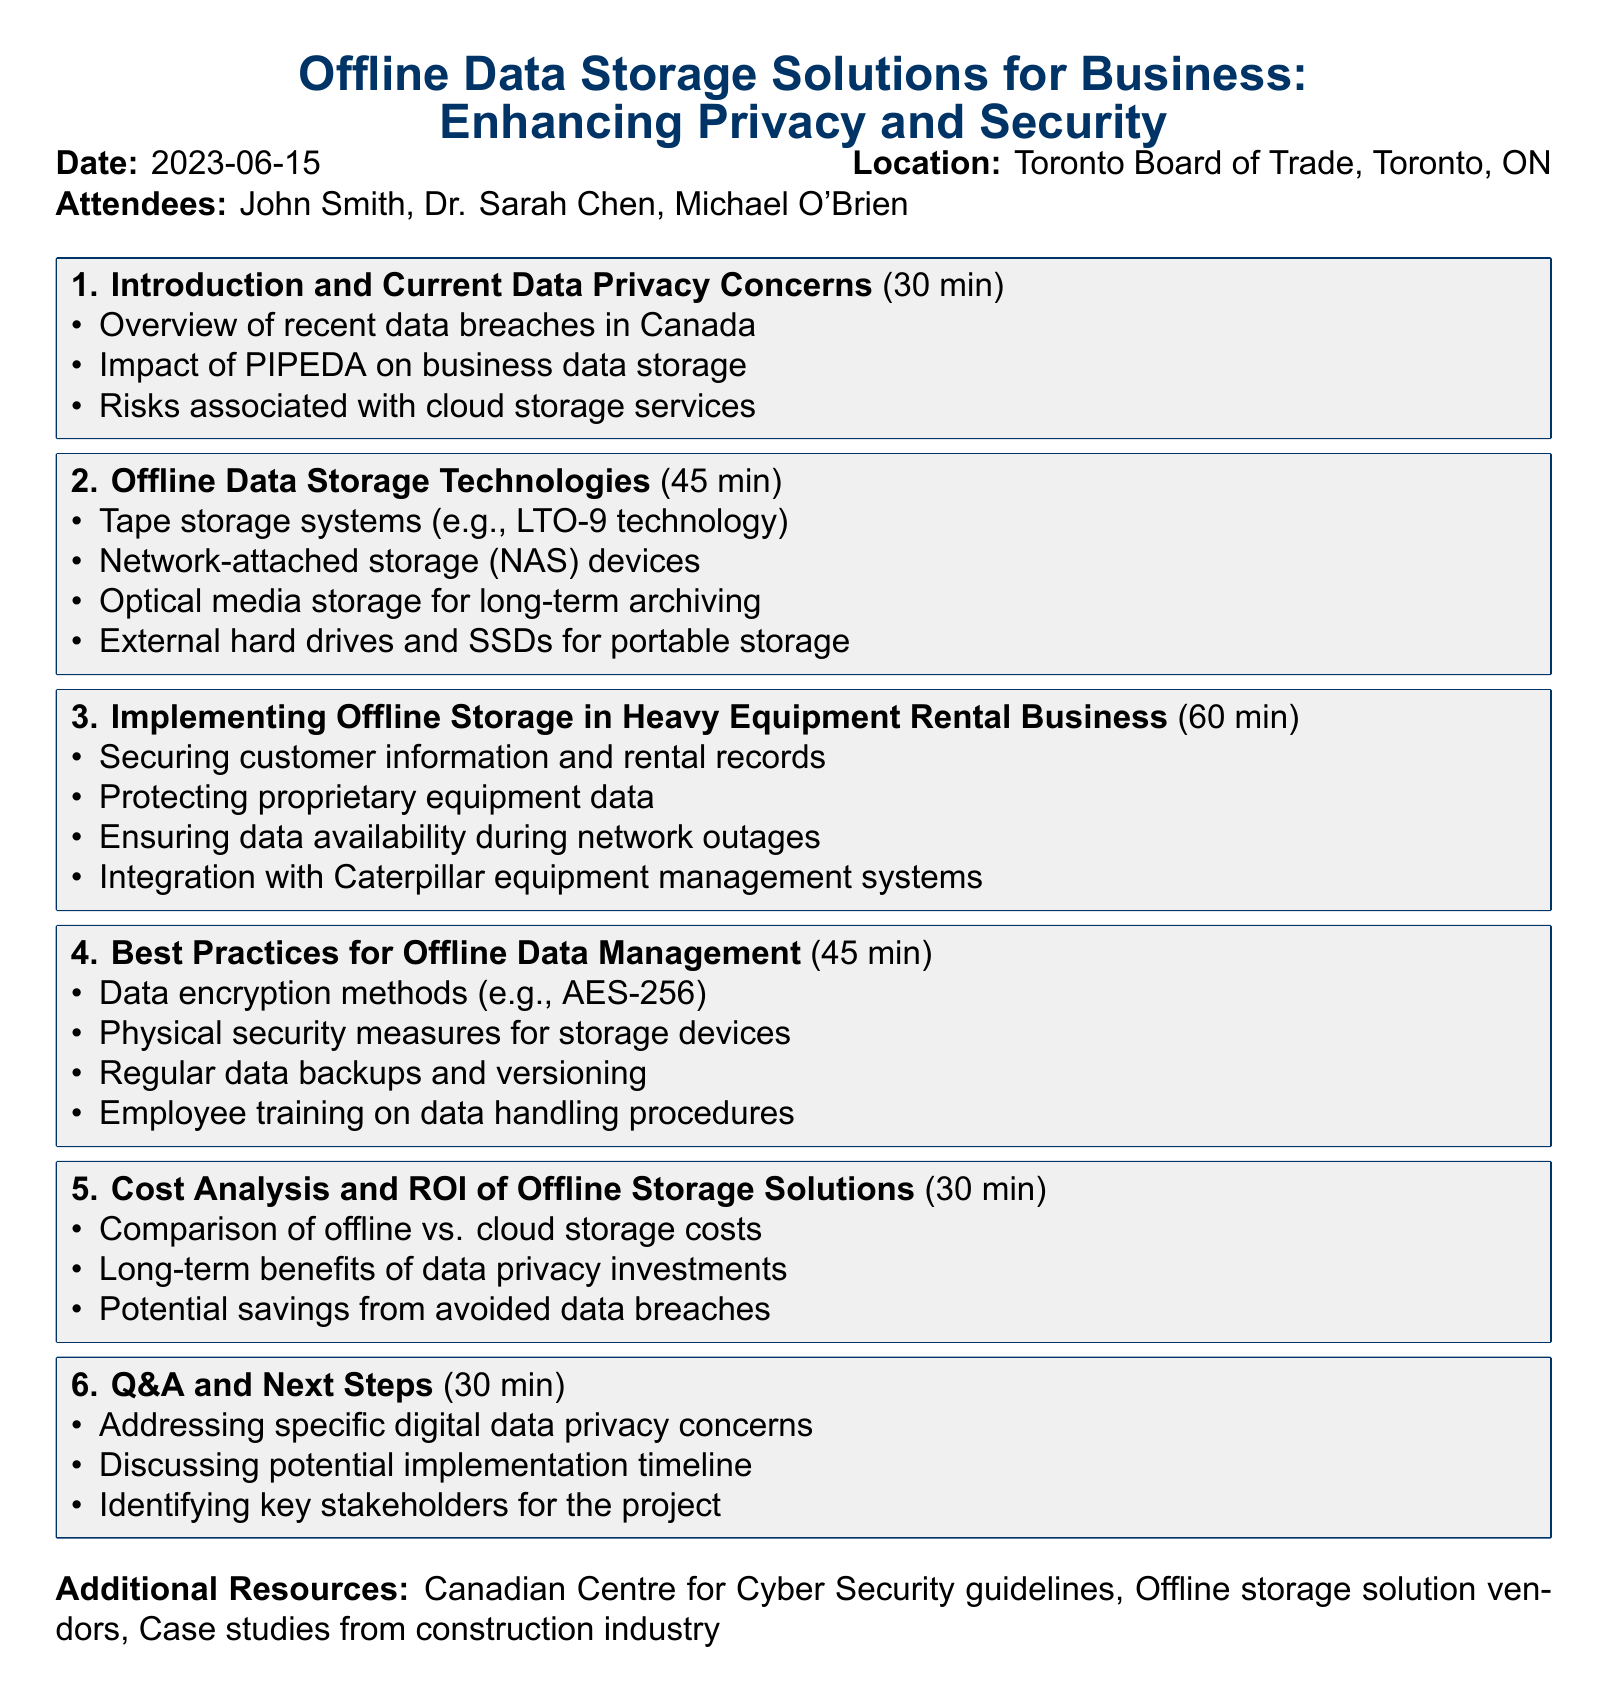What is the meeting title? The title is stated clearly at the beginning of the document, which is "Offline Data Storage Solutions for Business: Enhancing Privacy and Security."
Answer: Offline Data Storage Solutions for Business: Enhancing Privacy and Security Who is the cybersecurity expert attending the meeting? The document lists the attendees, including the cybersecurity expert named Dr. Sarah Chen from the University of Toronto.
Answer: Dr. Sarah Chen How long is the agenda item on Offline Data Storage Technologies? The duration for this agenda item is mentioned under the title, which is 45 minutes.
Answer: 45 minutes What is one method of data encryption mentioned in the document? The document provides an example of a data encryption method in the best practices section, which is AES-256.
Answer: AES-256 What is the primary concern addressed in the first agenda item? The first agenda item's topics include an overview of recent data breaches, making data privacy concerns the main focus.
Answer: Current Data Privacy Concerns How much time is allocated for Q&A and next steps? The document specifies the duration for this section as 30 minutes, listed under the agenda item.
Answer: 30 minutes What specific data is suggested to be secured in the heavy equipment rental business? The document lists securing customer information and rental records as a primary focus under this agenda item.
Answer: Customer information and rental records Which location is the meeting held at? The document states the meeting location as Toronto Board of Trade, providing the full address.
Answer: Toronto Board of Trade, 1 First Canadian Place, Toronto, ON M5X 1C1 What is one of the additional resources mentioned in the document? The additional resources section mentions the Canadian Centre for Cyber Security guidelines as a resource.
Answer: Canadian Centre for Cyber Security guidelines 